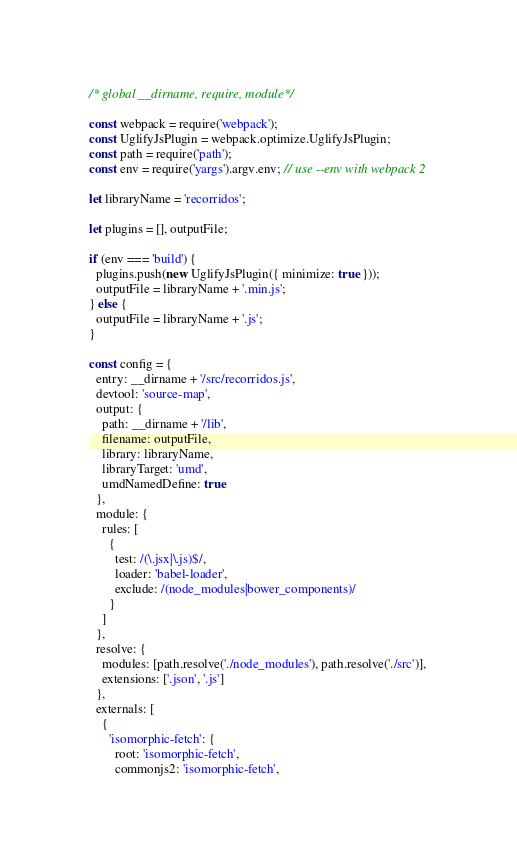Convert code to text. <code><loc_0><loc_0><loc_500><loc_500><_JavaScript_>/* global __dirname, require, module*/

const webpack = require('webpack');
const UglifyJsPlugin = webpack.optimize.UglifyJsPlugin;
const path = require('path');
const env = require('yargs').argv.env; // use --env with webpack 2

let libraryName = 'recorridos';

let plugins = [], outputFile;

if (env === 'build') {
  plugins.push(new UglifyJsPlugin({ minimize: true }));
  outputFile = libraryName + '.min.js';
} else {
  outputFile = libraryName + '.js';
}

const config = {
  entry: __dirname + '/src/recorridos.js',
  devtool: 'source-map',
  output: {
    path: __dirname + '/lib',
    filename: outputFile,
    library: libraryName,
    libraryTarget: 'umd',
    umdNamedDefine: true
  },
  module: {
    rules: [
      {
        test: /(\.jsx|\.js)$/,
        loader: 'babel-loader',
        exclude: /(node_modules|bower_components)/
      }
    ]
  },
  resolve: {
    modules: [path.resolve('./node_modules'), path.resolve('./src')],
    extensions: ['.json', '.js']
  },
  externals: [
    {
      'isomorphic-fetch': {
        root: 'isomorphic-fetch',
        commonjs2: 'isomorphic-fetch',</code> 